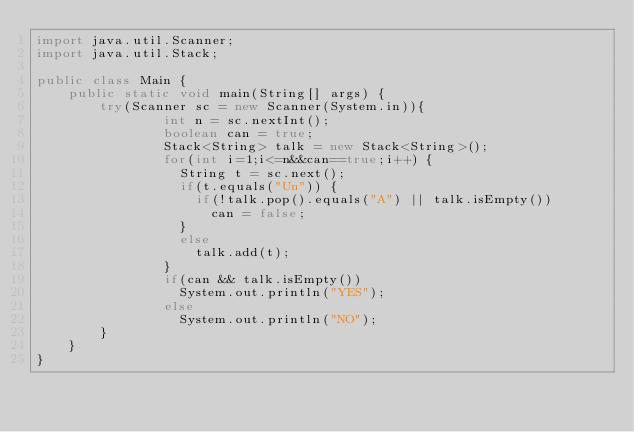Convert code to text. <code><loc_0><loc_0><loc_500><loc_500><_Java_>import java.util.Scanner;
import java.util.Stack;
 
public class Main {
    public static void main(String[] args) {
        try(Scanner sc = new Scanner(System.in)){
                int n = sc.nextInt();
                boolean can = true;
                Stack<String> talk = new Stack<String>();
                for(int i=1;i<=n&&can==true;i++) {
                	String t = sc.next();
                	if(t.equals("Un")) {
                		if(!talk.pop().equals("A") || talk.isEmpty())
                			can = false;
                	}
                	else
                		talk.add(t);
                }
                if(can && talk.isEmpty())
                	System.out.println("YES");
                else
                	System.out.println("NO");
        }
    }
}

</code> 